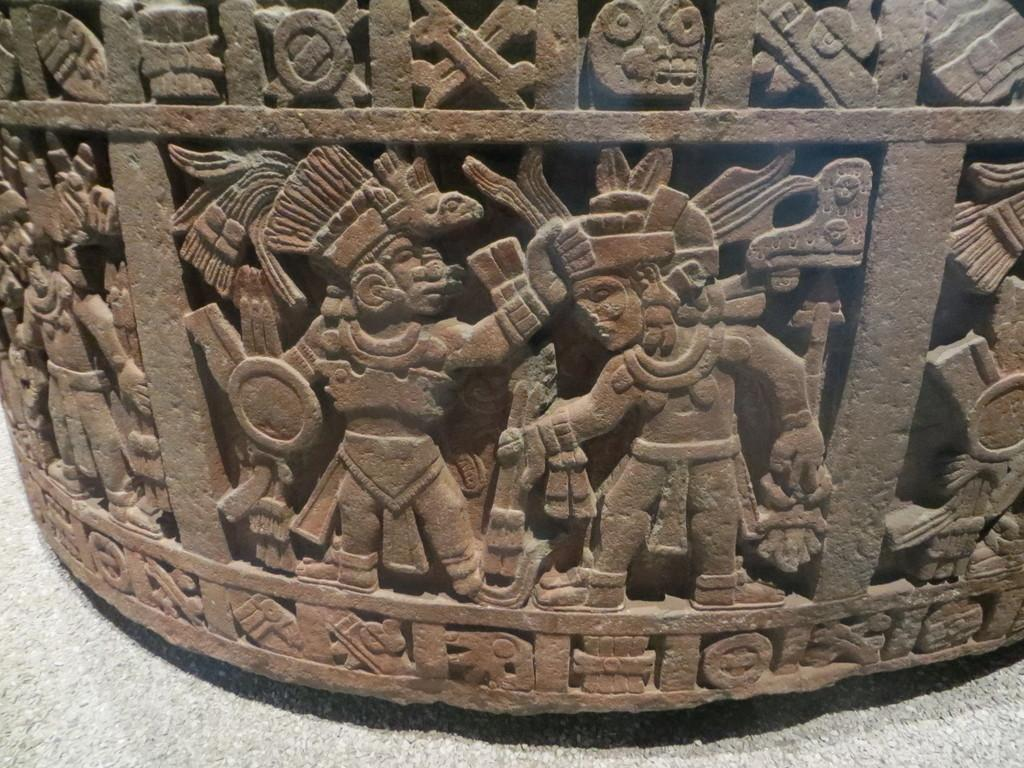What type of art is present in the image? There are sculptures in the image. What color are the sculptures? The sculptures are brown in color. What is the color of the surface at the bottom of the image? The surface at the bottom of the image is white in color. What type of scent can be detected from the sculptures in the image? There is no mention of a scent in the image, and sculptures typically do not have a scent. 